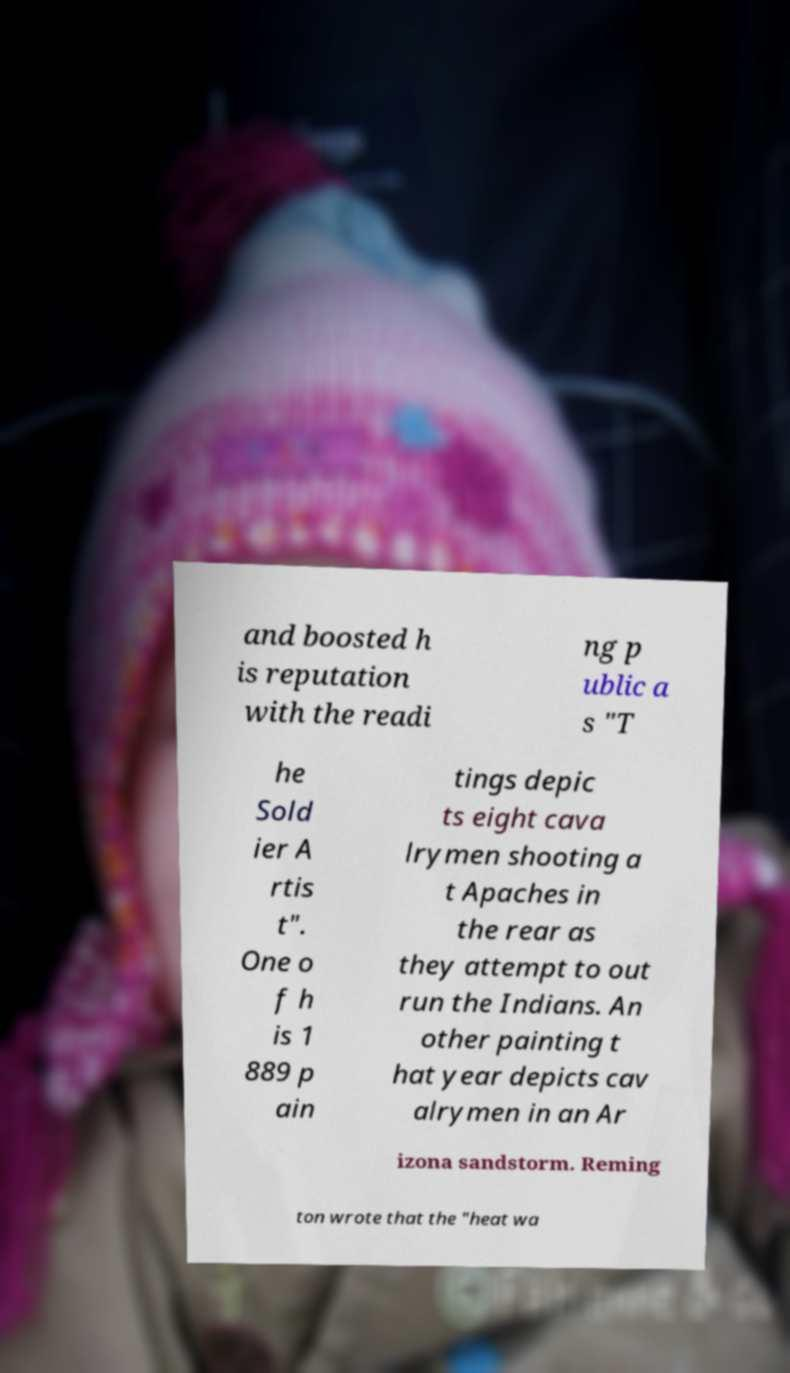Can you read and provide the text displayed in the image?This photo seems to have some interesting text. Can you extract and type it out for me? and boosted h is reputation with the readi ng p ublic a s "T he Sold ier A rtis t". One o f h is 1 889 p ain tings depic ts eight cava lrymen shooting a t Apaches in the rear as they attempt to out run the Indians. An other painting t hat year depicts cav alrymen in an Ar izona sandstorm. Reming ton wrote that the "heat wa 